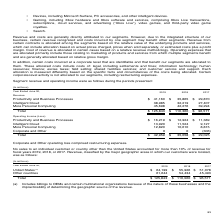According to Microsoft Corporation's financial document, How is the revenue from certain contracts allocated? Revenue from certain contracts is allocated among the segments based on the relative value of the underlying products and services, which can include allocation based on actual prices charged, prices when sold separately, or estimated costs plus a profit margin.. The document states: "ncurred by one segment may benefit other segments. Revenue from certain contracts is allocated among the segments based on the relative value of the u..." Also, How are operating expenses generally allocated? Operating expenses that are allocated primarily include those relating to marketing of products and services from which multiple segments benefit and are generally allocated based on relative gross margin.. The document states: "ain cases based on a relative revenue methodology. Operating expenses that are allocated primarily include those relating to marketing of products and..." Also, What do the allocated costs include? These allocated costs include costs of: legal, including settlements and fines; information technology; human resources; finance; excise taxes; field selling; shared facilities services; and customer service and support.. The document states: "d that benefit our segments are allocated to them. These allocated costs include costs of: legal, including settlements and fines; information technol..." Additionally, Which of the 3 years from 2017 to 2019 had the highest revenue for Intelligent Cloud? According to the financial document, 2019. The relevant text states: "Year Ended June 30, 2019 2018 2017..." Also, How many items are there for operating income (loss)? Counting the relevant items in the document: Productivity and Business Processes,  Intelligent Cloud,  More Personal Computing,  Corporate and Other, I find 4 instances. The key data points involved are: Corporate and Other, Intelligent Cloud, More Personal Computing. Additionally, How many of the 3 years from 2017 to 2019 had operating income of less than $14,000 million for productivity and business processes? According to the financial document, 2. The relevant text states: "Year Ended June 30, 2019 2018 2017..." 